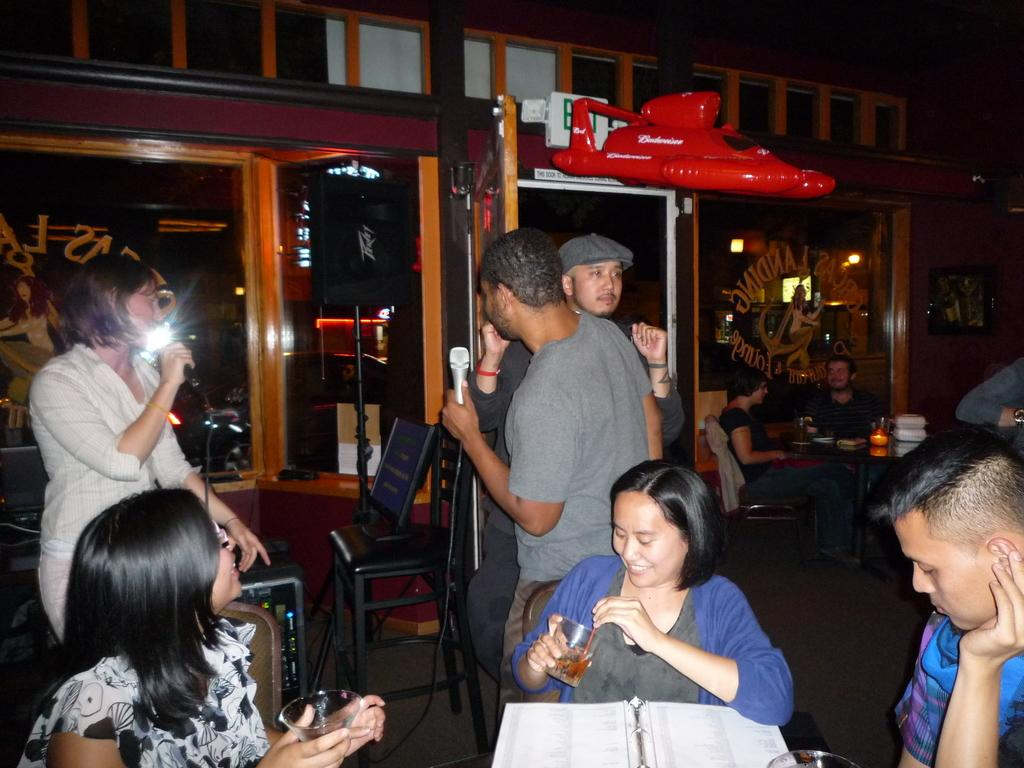What are the people in the image doing? The people in the image are standing and holding microphones in their hands. Are there any other people in the image? Yes, there are people sitting in chairs in the image. What can be seen in the background of the image? There is a wall and a balloon toy in the background of the image. What type of hook is being used to hang the fairies in the image? There are no fairies or hooks present in the image. 